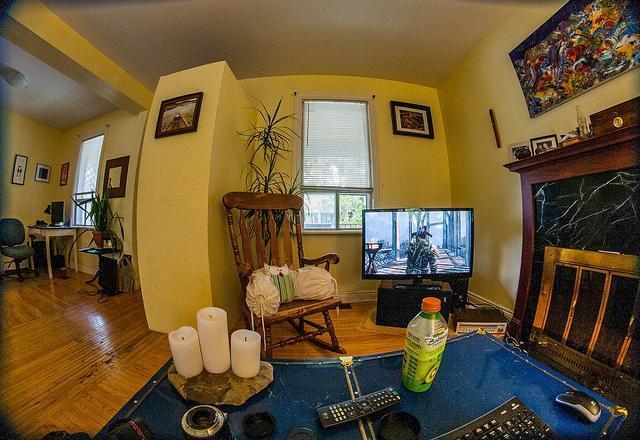How many candles are there?
Give a very brief answer. 3. How many windows do you see?
Give a very brief answer. 2. How many keyboards are there?
Give a very brief answer. 1. How many chairs are there?
Give a very brief answer. 2. 